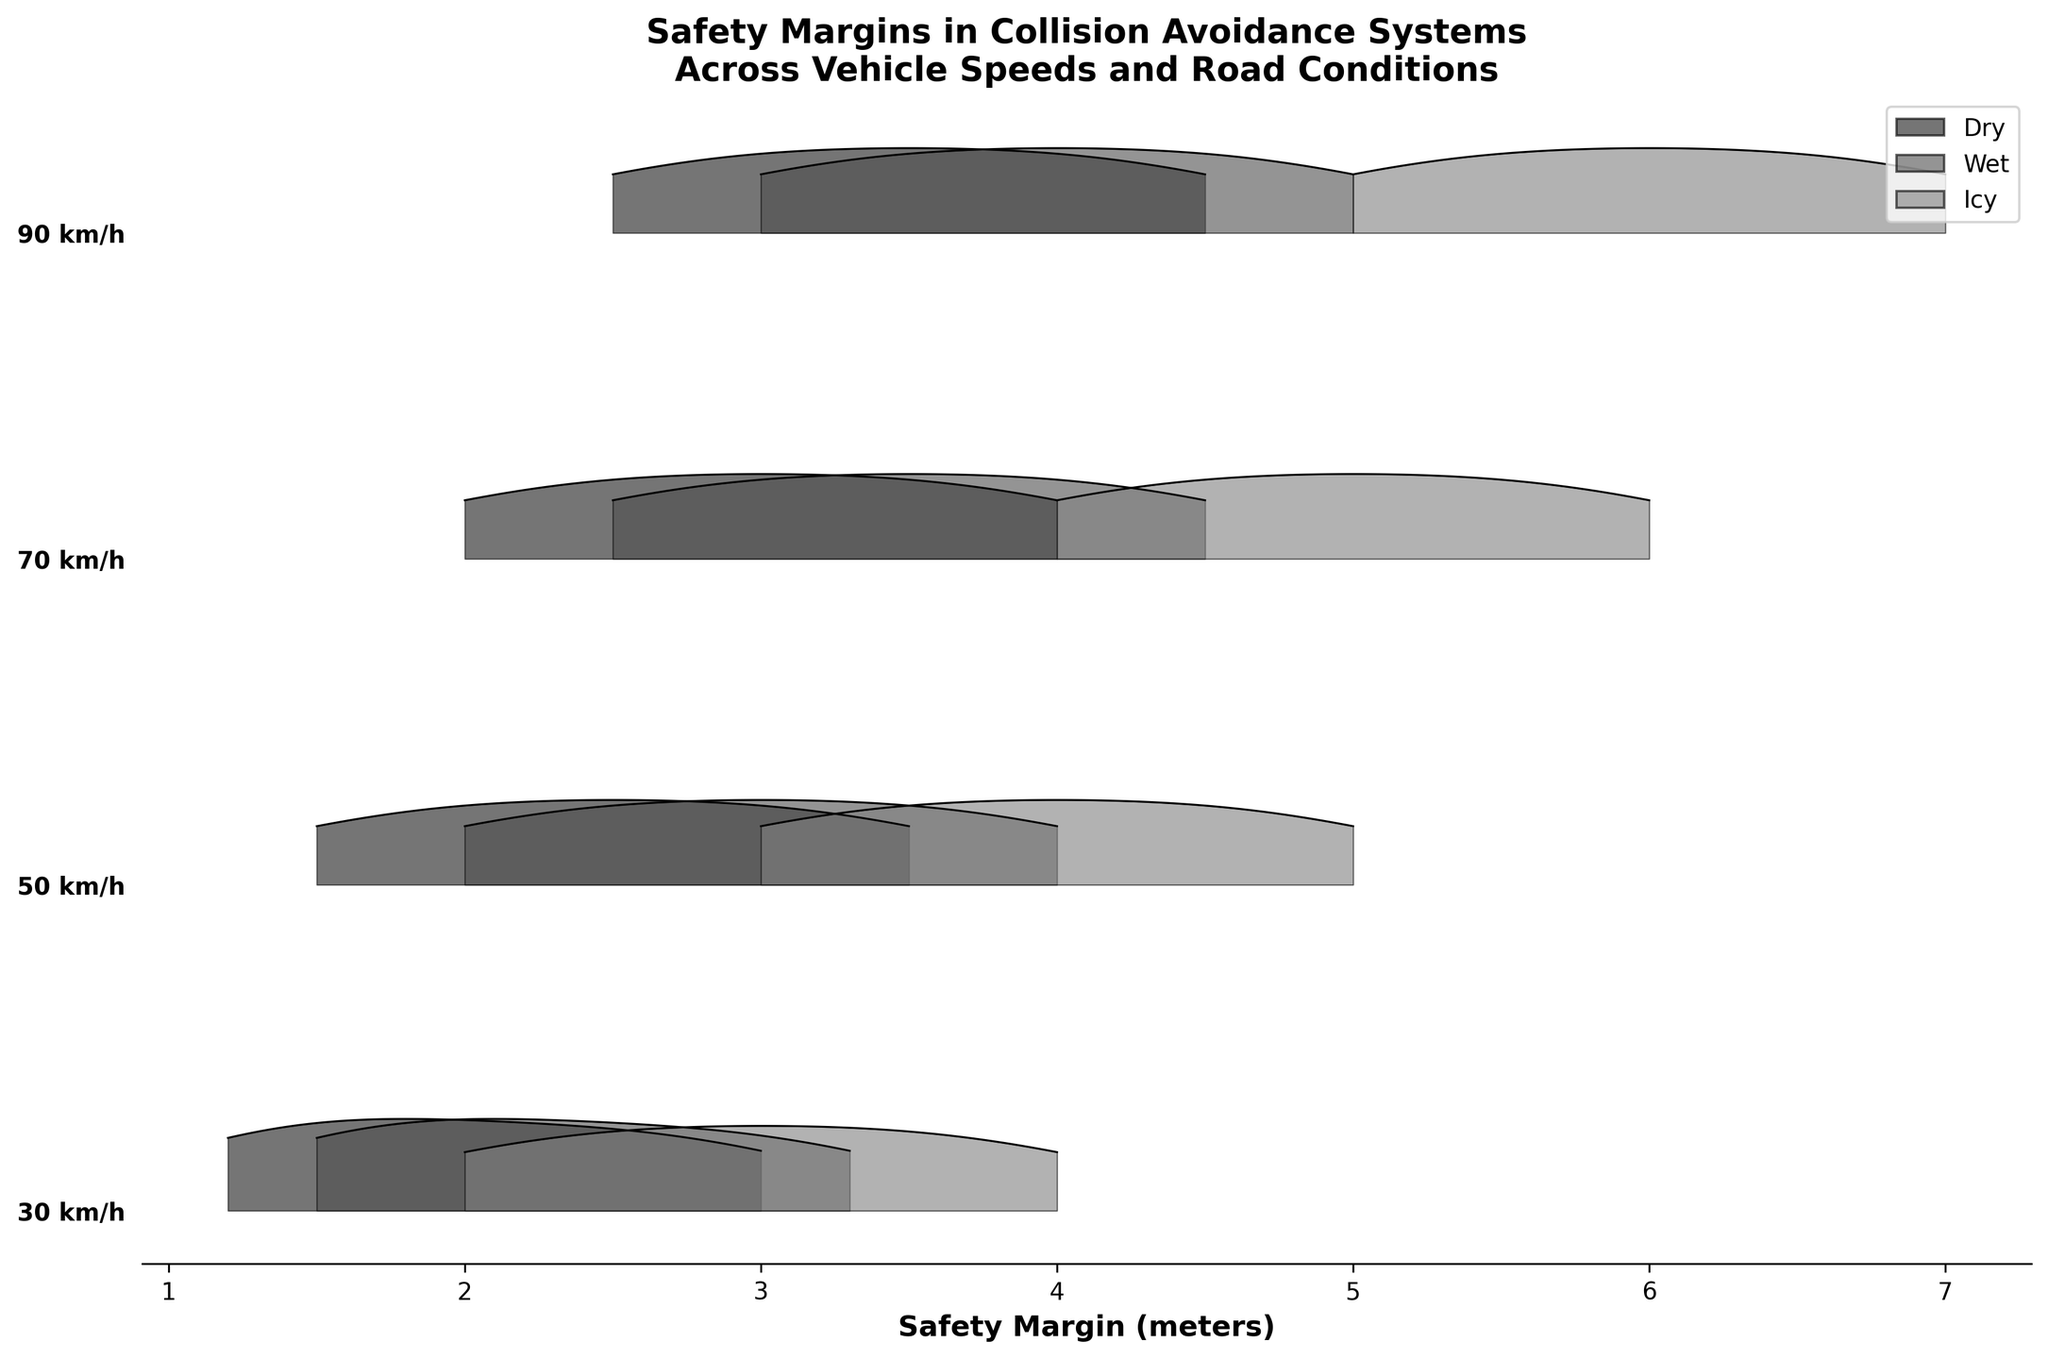Which vehicle speed shows the highest safety margin, and under what road condition? The highest safety margin is evident in the ridgeline plot where the curve is most shifted to the right. This occurs for the 90 km/h speed under icy road conditions.
Answer: 90 km/h, icy How does the safety margin under wet conditions at 50 km/h compare to icy conditions at 50 km/h? Under 50 km/h, the safety margins for wet conditions range from 2.0 to 4.0 meters, while for icy conditions, they range from 3.0 to 5.0 meters, indicating that icy conditions have higher safety margins.
Answer: Icy conditions have higher safety margins What can you infer about the relationship between vehicle speed and safety margins on icy roads? As vehicle speed increases, the safety margins on icy roads also increase significantly, with higher speeds (70 km/h and 90 km/h) showing much larger safety margins than lower speeds (30 km/h and 50 km/h).
Answer: Higher speed, higher margins on icy roads Which road condition consistently shows the smallest safety margins across all speeds? Dry road conditions consistently have the smallest safety margins across all speeds, as seen by the leftmost ridgeline plots for each speed level.
Answer: Dry At 70 km/h, what is the range of safety margins for dry conditions? Observing the ridgeline plot for 70 km/h under dry conditions, the safety margins range from 2.0 to 4.0 meters.
Answer: 2.0 to 4.0 meters How do the safety margins at 30 km/h on wet roads compare to 90 km/h on wet roads? At 30 km/h on wet roads, the safety margins range from 1.5 to 3.3 meters, whereas at 90 km/h on wet roads, the safety margins range from 3.0 to 5.0 meters. This shows that higher speeds have significantly higher safety margins on wet roads.
Answer: 90 km/h has higher margins Which vehicle speed under dry conditions has the most symmetrical safety margin distribution? By inspecting the shape of the ridgeline plots, the 70 km/h speed under dry conditions appears to have the most symmetrical distribution.
Answer: 70 km/h How does changing road conditions from dry to icy affect safety margins at 50 km/h? At 50 km/h, changing from dry (1.5 to 3.5 meters) to icy conditions (3.0 to 5.0 meters) significantly increases the safety margins.
Answer: Safety margins increase What's the vehicle speed for which wet and icy road conditions have almost overlapping safety margin ranges? At 70 km/h, the safety margins for wet and icy conditions appear to almost overlap closely based on the ridgeline plots, showing minimal distance between them.
Answer: 70 km/h 